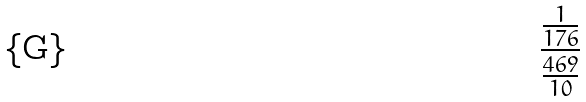Convert formula to latex. <formula><loc_0><loc_0><loc_500><loc_500>\frac { \frac { 1 } { 1 7 6 } } { \frac { 4 6 9 } { 1 0 } }</formula> 